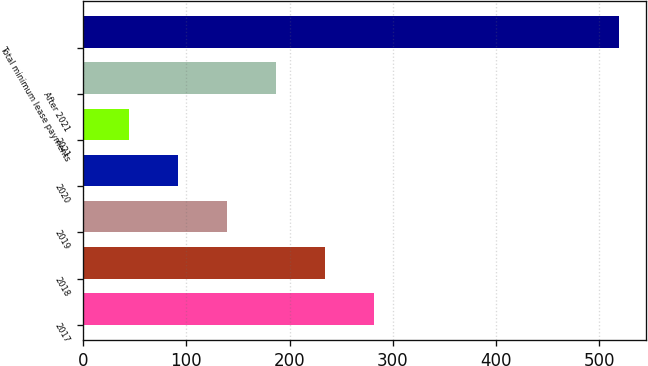<chart> <loc_0><loc_0><loc_500><loc_500><bar_chart><fcel>2017<fcel>2018<fcel>2019<fcel>2020<fcel>2021<fcel>After 2021<fcel>Total minimum lease payments<nl><fcel>281.5<fcel>234<fcel>139<fcel>91.5<fcel>44<fcel>186.5<fcel>519<nl></chart> 